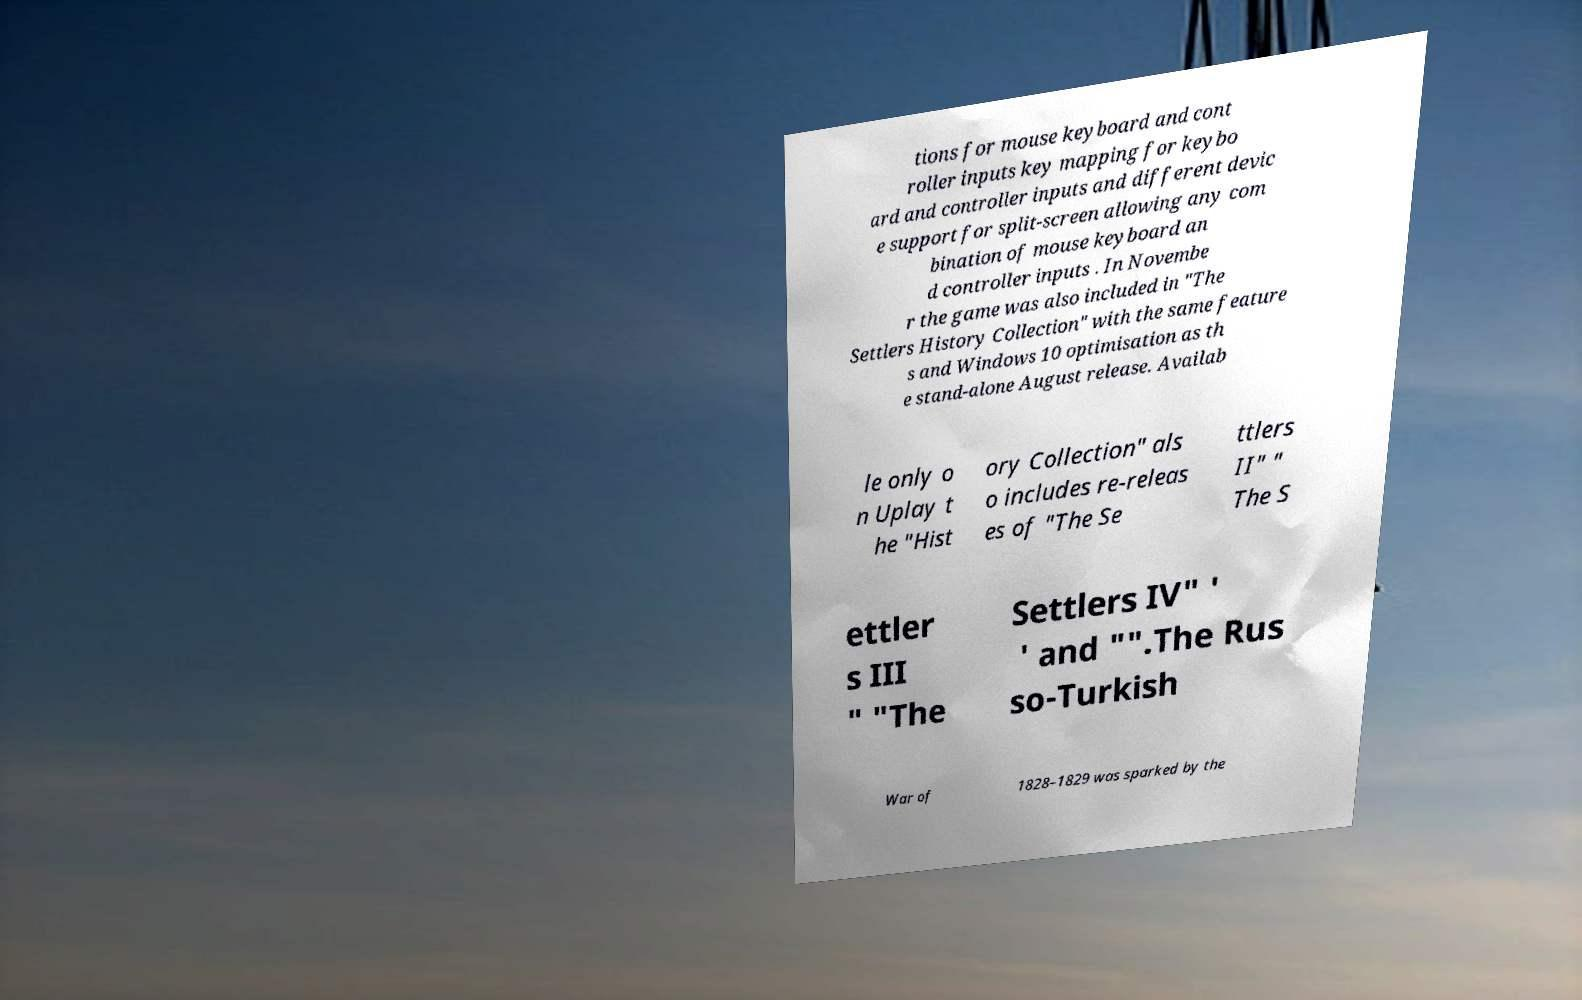What messages or text are displayed in this image? I need them in a readable, typed format. tions for mouse keyboard and cont roller inputs key mapping for keybo ard and controller inputs and different devic e support for split-screen allowing any com bination of mouse keyboard an d controller inputs . In Novembe r the game was also included in "The Settlers History Collection" with the same feature s and Windows 10 optimisation as th e stand-alone August release. Availab le only o n Uplay t he "Hist ory Collection" als o includes re-releas es of "The Se ttlers II" " The S ettler s III " "The Settlers IV" ' ' and "".The Rus so-Turkish War of 1828–1829 was sparked by the 